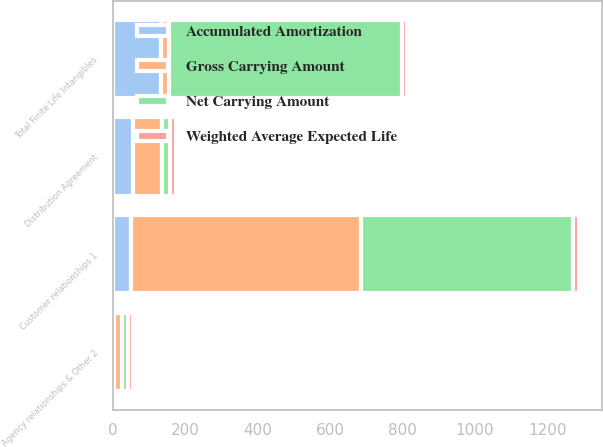<chart> <loc_0><loc_0><loc_500><loc_500><stacked_bar_chart><ecel><fcel>Customer relationships 1<fcel>Distribution Agreement<fcel>Agency relationships & Other 2<fcel>Total Finite Life Intangibles<nl><fcel>Gross Carrying Amount<fcel>636<fcel>79<fcel>21<fcel>23<nl><fcel>Accumulated Amortization<fcel>49<fcel>56<fcel>3<fcel>132<nl><fcel>Net Carrying Amount<fcel>587<fcel>23<fcel>18<fcel>643<nl><fcel>Weighted Average Expected Life<fcel>15<fcel>15<fcel>13<fcel>14<nl></chart> 